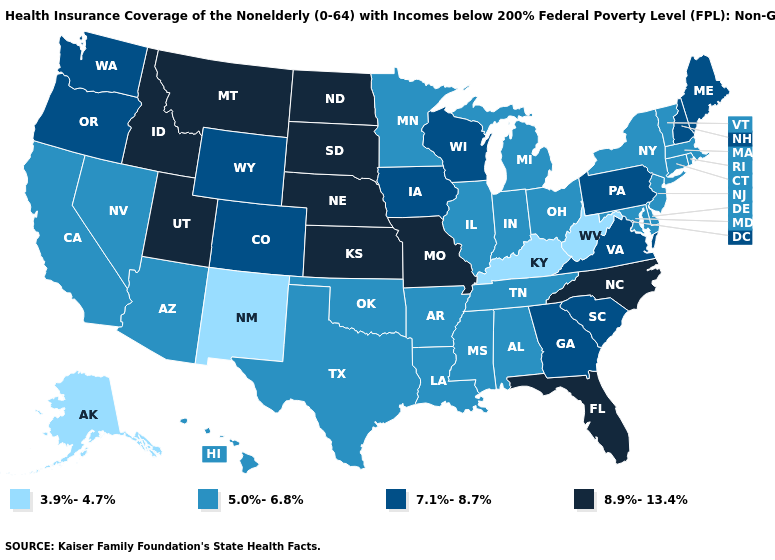Name the states that have a value in the range 7.1%-8.7%?
Be succinct. Colorado, Georgia, Iowa, Maine, New Hampshire, Oregon, Pennsylvania, South Carolina, Virginia, Washington, Wisconsin, Wyoming. Does the map have missing data?
Write a very short answer. No. Is the legend a continuous bar?
Keep it brief. No. Does Maryland have the same value as Vermont?
Write a very short answer. Yes. Is the legend a continuous bar?
Answer briefly. No. What is the value of Delaware?
Be succinct. 5.0%-6.8%. Name the states that have a value in the range 7.1%-8.7%?
Be succinct. Colorado, Georgia, Iowa, Maine, New Hampshire, Oregon, Pennsylvania, South Carolina, Virginia, Washington, Wisconsin, Wyoming. Which states have the highest value in the USA?
Concise answer only. Florida, Idaho, Kansas, Missouri, Montana, Nebraska, North Carolina, North Dakota, South Dakota, Utah. What is the highest value in the Northeast ?
Write a very short answer. 7.1%-8.7%. What is the value of South Carolina?
Keep it brief. 7.1%-8.7%. Is the legend a continuous bar?
Keep it brief. No. Name the states that have a value in the range 8.9%-13.4%?
Concise answer only. Florida, Idaho, Kansas, Missouri, Montana, Nebraska, North Carolina, North Dakota, South Dakota, Utah. What is the highest value in the Northeast ?
Give a very brief answer. 7.1%-8.7%. Among the states that border Illinois , does Kentucky have the lowest value?
Concise answer only. Yes. Name the states that have a value in the range 8.9%-13.4%?
Answer briefly. Florida, Idaho, Kansas, Missouri, Montana, Nebraska, North Carolina, North Dakota, South Dakota, Utah. 